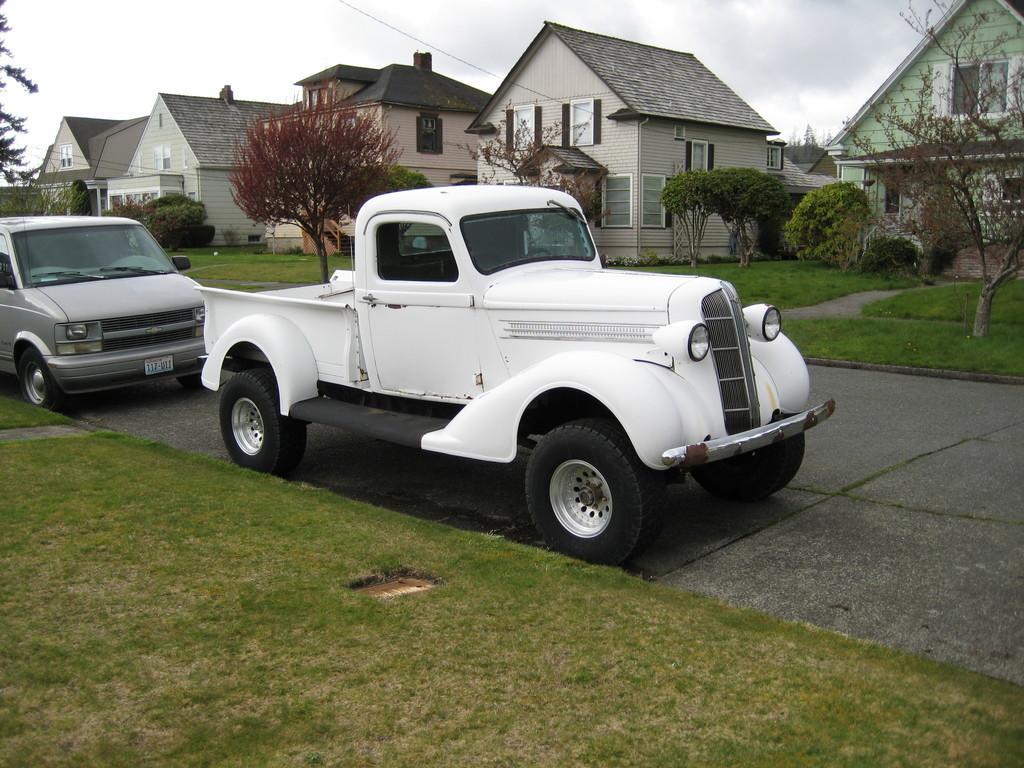How would you summarize this image in a sentence or two? In this image I can see the ground, few vehicles on the ground, some grass, few trees and few buildings. In the background I can see the sky. 